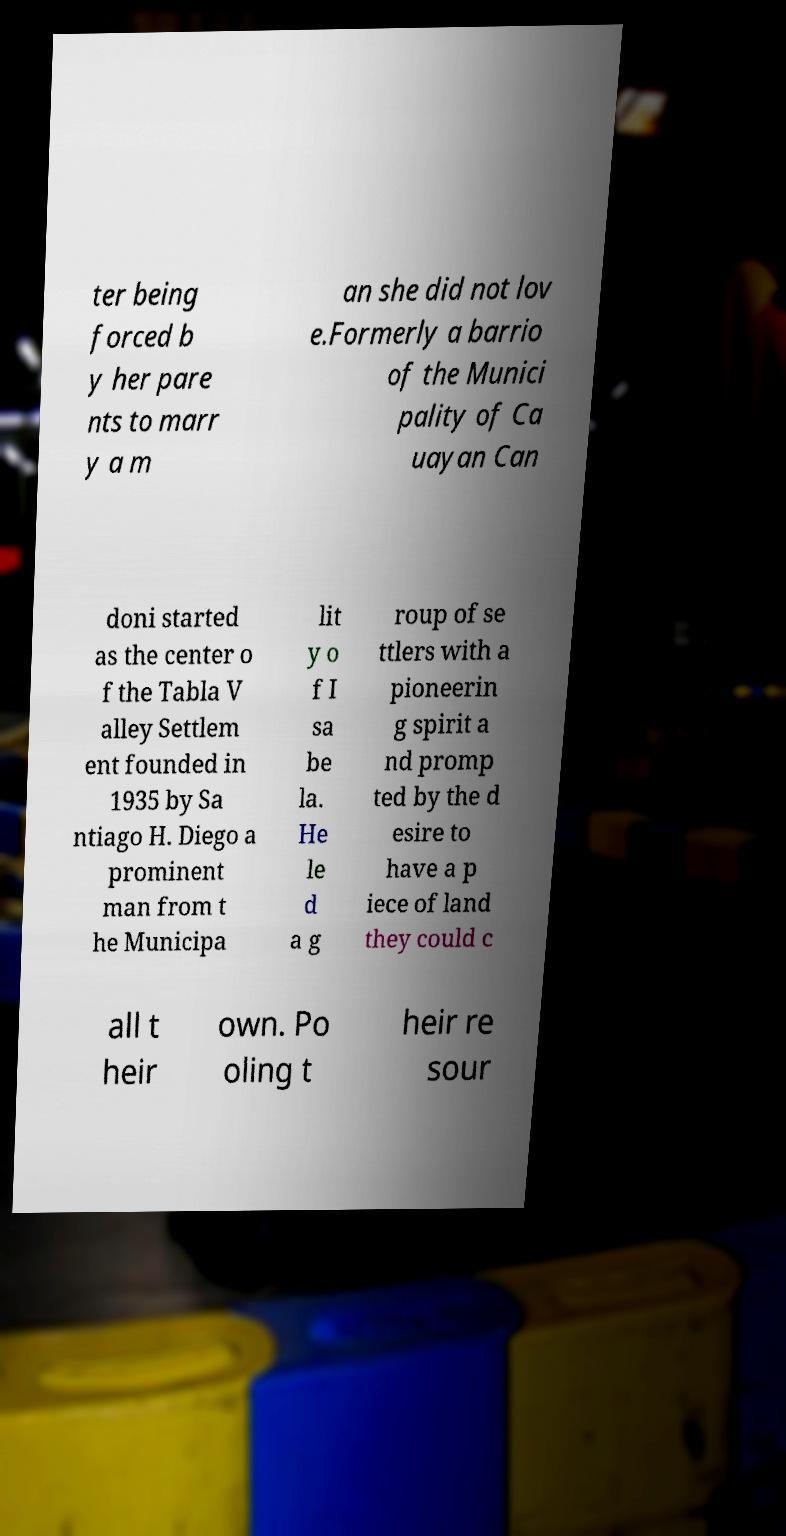There's text embedded in this image that I need extracted. Can you transcribe it verbatim? ter being forced b y her pare nts to marr y a m an she did not lov e.Formerly a barrio of the Munici pality of Ca uayan Can doni started as the center o f the Tabla V alley Settlem ent founded in 1935 by Sa ntiago H. Diego a prominent man from t he Municipa lit y o f I sa be la. He le d a g roup of se ttlers with a pioneerin g spirit a nd promp ted by the d esire to have a p iece of land they could c all t heir own. Po oling t heir re sour 